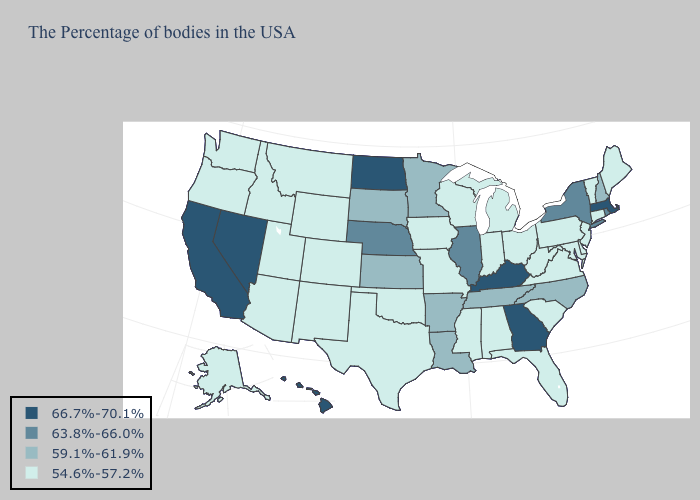Does Massachusetts have the highest value in the Northeast?
Give a very brief answer. Yes. What is the value of New Hampshire?
Keep it brief. 59.1%-61.9%. Name the states that have a value in the range 54.6%-57.2%?
Quick response, please. Maine, Vermont, Connecticut, New Jersey, Delaware, Maryland, Pennsylvania, Virginia, South Carolina, West Virginia, Ohio, Florida, Michigan, Indiana, Alabama, Wisconsin, Mississippi, Missouri, Iowa, Oklahoma, Texas, Wyoming, Colorado, New Mexico, Utah, Montana, Arizona, Idaho, Washington, Oregon, Alaska. Does Arizona have the same value as New Hampshire?
Be succinct. No. What is the value of Minnesota?
Give a very brief answer. 59.1%-61.9%. Which states have the lowest value in the Northeast?
Quick response, please. Maine, Vermont, Connecticut, New Jersey, Pennsylvania. Name the states that have a value in the range 66.7%-70.1%?
Concise answer only. Massachusetts, Georgia, Kentucky, North Dakota, Nevada, California, Hawaii. Does Nevada have the lowest value in the USA?
Concise answer only. No. What is the value of Virginia?
Answer briefly. 54.6%-57.2%. What is the value of Nevada?
Write a very short answer. 66.7%-70.1%. What is the value of Louisiana?
Keep it brief. 59.1%-61.9%. What is the value of Montana?
Be succinct. 54.6%-57.2%. Among the states that border Minnesota , which have the lowest value?
Be succinct. Wisconsin, Iowa. Does South Dakota have the lowest value in the MidWest?
Quick response, please. No. What is the value of Alaska?
Short answer required. 54.6%-57.2%. 